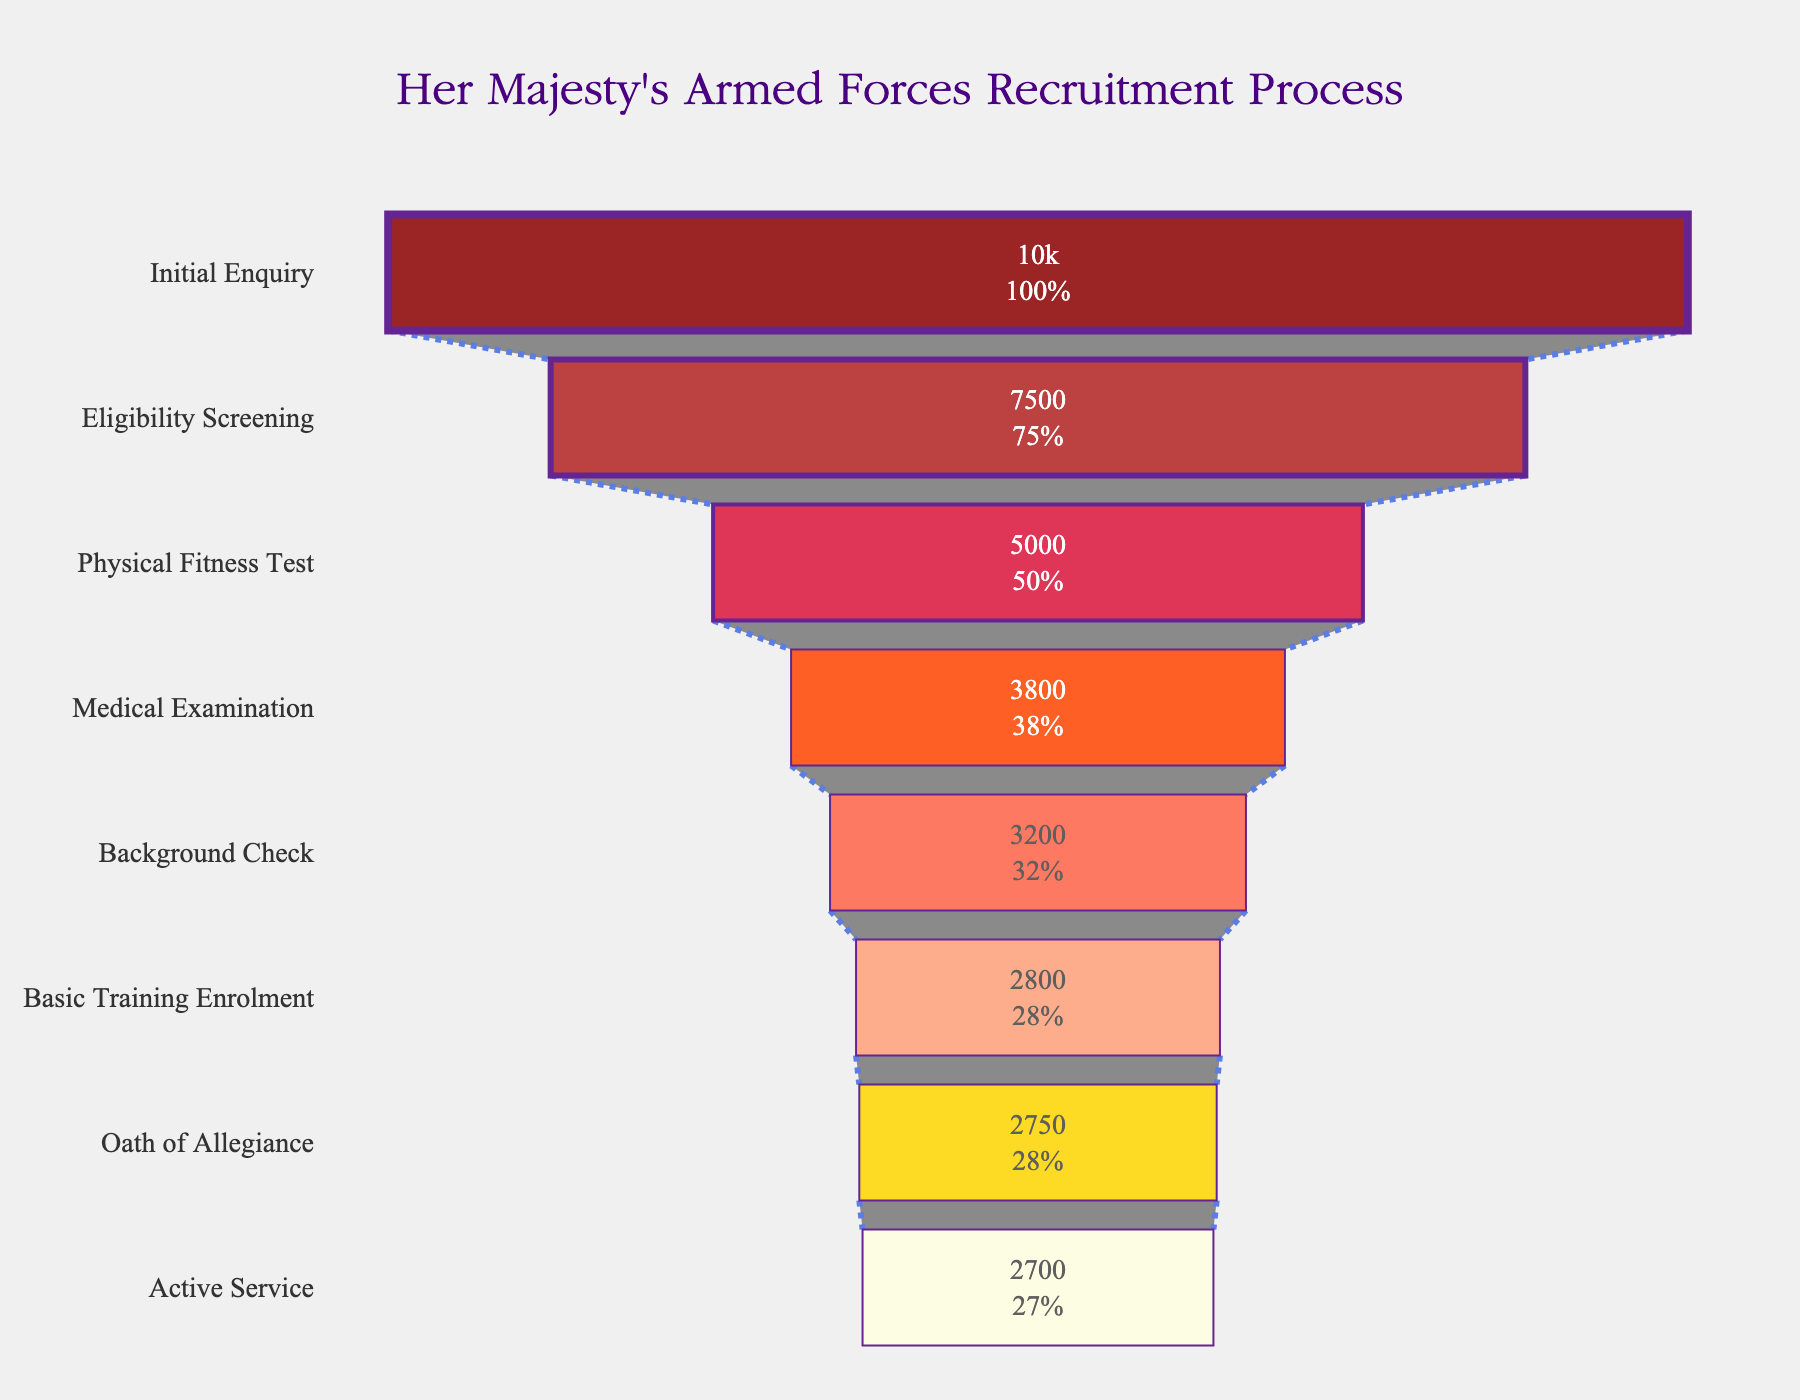What's the title of the chart? The title of the chart can be seen at the top of the figure in a prominent position. It reads, "Her Majesty's Armed Forces Recruitment Process".
Answer: Her Majesty's Armed Forces Recruitment Process What is the percentage of applicants who advanced from the Physical Fitness Test to the Medical Examination? To find this percentage, we look at the values for the Physical Fitness Test (5000) and Medical Examination (3800). The percentage is calculated as (3800 / 5000) * 100.
Answer: 76% Which stage has the highest attrition rate? The highest attrition rate can be found by comparing the drop in the number of applicants between each stage. The stage with the largest numerical drop signifies the highest attrition rate. The largest drop is between Initial Enquiry (10000) and Eligibility Screening (7500) which is 2500 applicants.
Answer: Initial Enquiry to Eligibility Screening How many applicants successfully reached Active Service? The number of applicants who successfully reached Active Service is the value provided at the bottom-most stage of the funnel. This value is 2700 applicants.
Answer: 2700 What is the difference in the number of applicants between the Medical Examination and Background Check stages? The number of applicants in the Medical Examination stage is 3800, and in the Background Check stage, it is 3200. The difference is calculated as 3800 - 3200.
Answer: 600 What percentage of initial applicants reached the Oath of Allegiance? To find this percentage, look at the number of applicants at the Oath of Allegiance stage (2750) and divide by the initial number of applicants (10000), then multiply by 100.
Answer: 27.5% Was there a significant drop in applicants between any stages towards the end of the process? We can determine if there's a significant drop by comparing the values towards the end of the process. Between Basic Training Enrolment (2800) and Oath of Allegiance (2750), the drop is only 50 applicants which is not significant compared to earlier stages.
Answer: No At which stage did the most significant improvement in retention rate occur compared to the previous stage? Analyzing the different stages, the stage of Basic Training Enrolment (2800) compared with the Background Check (3200) shows a relatively low drop of 400, indicating a higher retention rate of 87.5%.
Answer: Basic Training Enrolment How does the number of applicants in Basic Training Enrolment compare with those in Active Service? To compare the number of applicants in these stages, we see that Basic Training Enrolment has 2800 applicants, and Active Service has 2700 applicants. The comparison shows that both stages have very close numbers with only 100 applicants difference.
Answer: Very close What is the color pattern followed in the stages of the funnel chart? The funnel chart uses a gradient color pattern starting from dark red at the top (Initial Enquiry) to lighter shades of red and finally yellow at the bottom (Active Service), representing a transition.
Answer: Gradient from dark red to yellow 